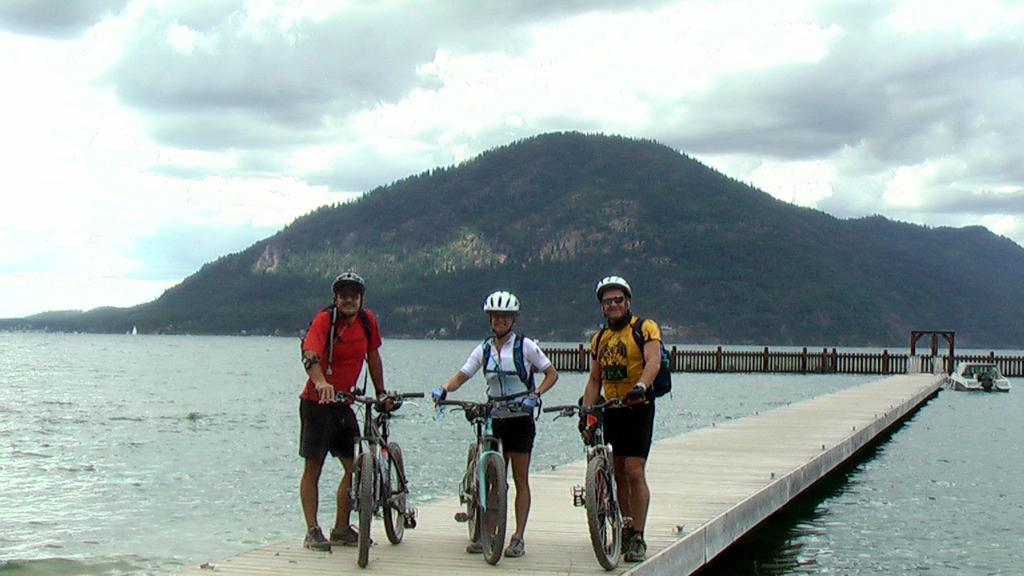Could you give a brief overview of what you see in this image? In this image, there are a few people holding bicycles. We can see some water with a few objects floating on it. We can also see some hills and the fence. We can also see the sky with clouds. We can also see a path above the water. 